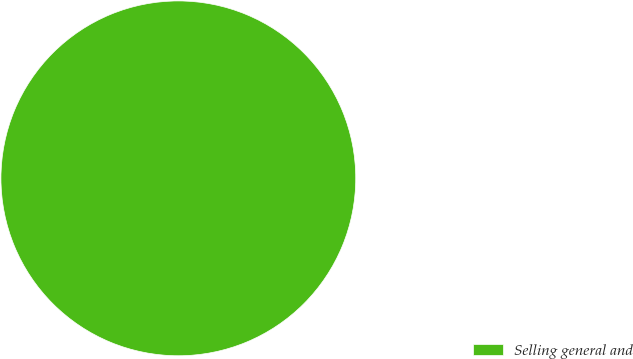<chart> <loc_0><loc_0><loc_500><loc_500><pie_chart><fcel>Selling general and<nl><fcel>100.0%<nl></chart> 